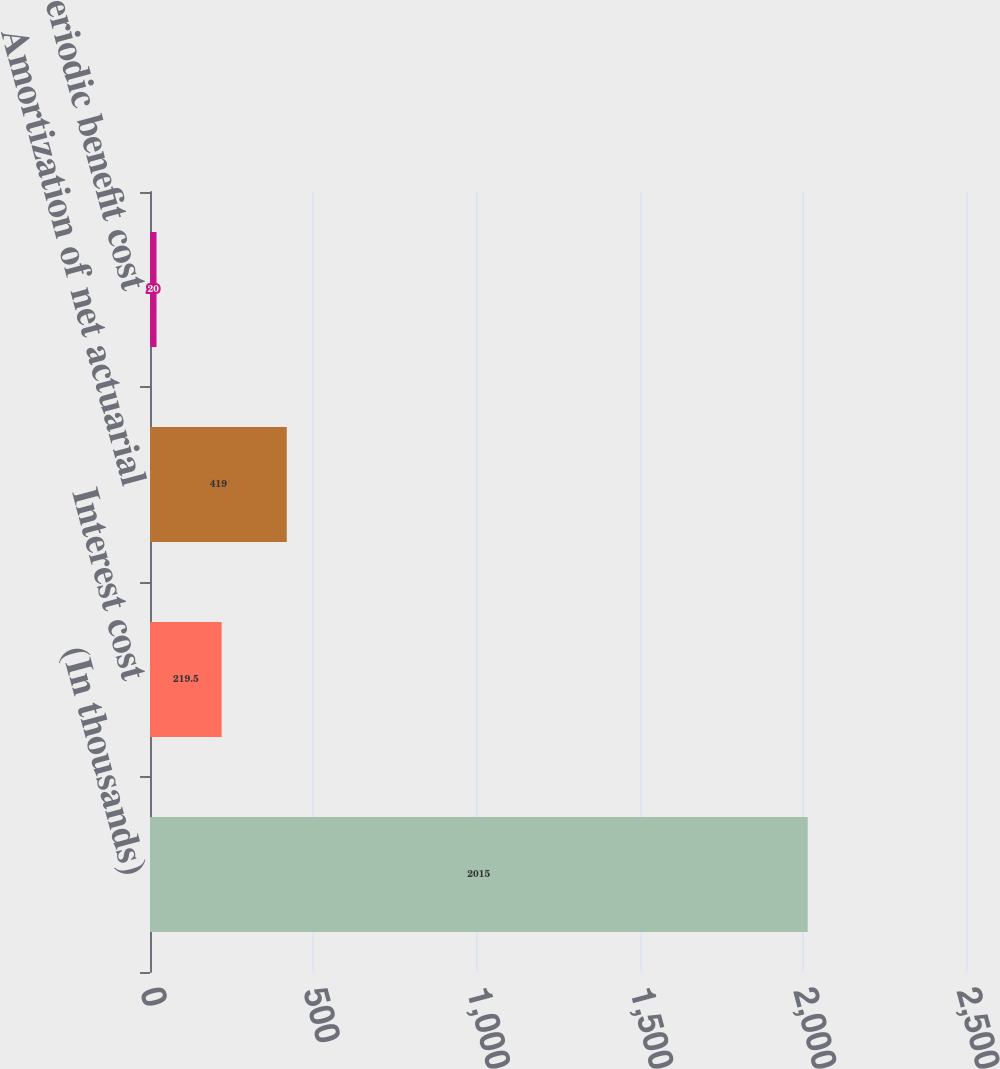Convert chart. <chart><loc_0><loc_0><loc_500><loc_500><bar_chart><fcel>(In thousands)<fcel>Interest cost<fcel>Amortization of net actuarial<fcel>Net periodic benefit cost<nl><fcel>2015<fcel>219.5<fcel>419<fcel>20<nl></chart> 